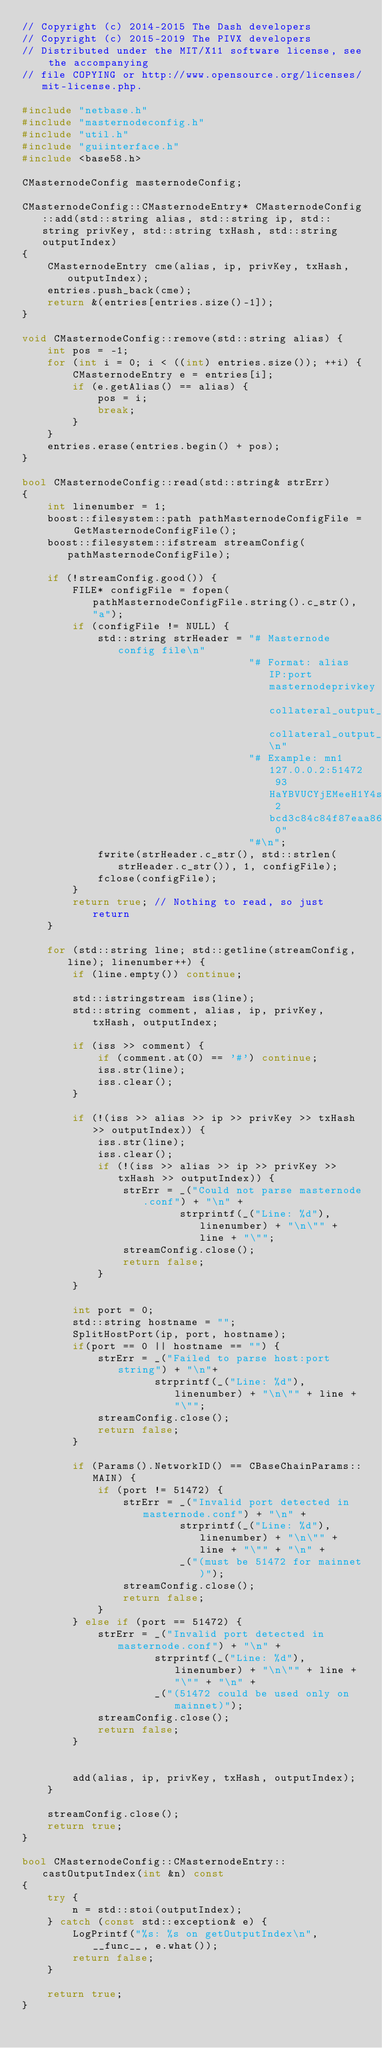<code> <loc_0><loc_0><loc_500><loc_500><_C++_>// Copyright (c) 2014-2015 The Dash developers
// Copyright (c) 2015-2019 The PIVX developers
// Distributed under the MIT/X11 software license, see the accompanying
// file COPYING or http://www.opensource.org/licenses/mit-license.php.

#include "netbase.h"
#include "masternodeconfig.h"
#include "util.h"
#include "guiinterface.h"
#include <base58.h>

CMasternodeConfig masternodeConfig;

CMasternodeConfig::CMasternodeEntry* CMasternodeConfig::add(std::string alias, std::string ip, std::string privKey, std::string txHash, std::string outputIndex)
{
    CMasternodeEntry cme(alias, ip, privKey, txHash, outputIndex);
    entries.push_back(cme);
    return &(entries[entries.size()-1]);
}

void CMasternodeConfig::remove(std::string alias) {
    int pos = -1;
    for (int i = 0; i < ((int) entries.size()); ++i) {
        CMasternodeEntry e = entries[i];
        if (e.getAlias() == alias) {
            pos = i;
            break;
        }
    }
    entries.erase(entries.begin() + pos);
}

bool CMasternodeConfig::read(std::string& strErr)
{
    int linenumber = 1;
    boost::filesystem::path pathMasternodeConfigFile = GetMasternodeConfigFile();
    boost::filesystem::ifstream streamConfig(pathMasternodeConfigFile);

    if (!streamConfig.good()) {
        FILE* configFile = fopen(pathMasternodeConfigFile.string().c_str(), "a");
        if (configFile != NULL) {
            std::string strHeader = "# Masternode config file\n"
                                    "# Format: alias IP:port masternodeprivkey collateral_output_txid collateral_output_index\n"
                                    "# Example: mn1 127.0.0.2:51472 93HaYBVUCYjEMeeH1Y4sBGLALQZE1Yc1K64xiqgX37tGBDQL8Xg 2bcd3c84c84f87eaa86e4e56834c92927a07f9e18718810b92e0d0324456a67c 0"
                                    "#\n";
            fwrite(strHeader.c_str(), std::strlen(strHeader.c_str()), 1, configFile);
            fclose(configFile);
        }
        return true; // Nothing to read, so just return
    }

    for (std::string line; std::getline(streamConfig, line); linenumber++) {
        if (line.empty()) continue;

        std::istringstream iss(line);
        std::string comment, alias, ip, privKey, txHash, outputIndex;

        if (iss >> comment) {
            if (comment.at(0) == '#') continue;
            iss.str(line);
            iss.clear();
        }

        if (!(iss >> alias >> ip >> privKey >> txHash >> outputIndex)) {
            iss.str(line);
            iss.clear();
            if (!(iss >> alias >> ip >> privKey >> txHash >> outputIndex)) {
                strErr = _("Could not parse masternode.conf") + "\n" +
                         strprintf(_("Line: %d"), linenumber) + "\n\"" + line + "\"";
                streamConfig.close();
                return false;
            }
        }

        int port = 0;
        std::string hostname = "";
        SplitHostPort(ip, port, hostname);
        if(port == 0 || hostname == "") {
            strErr = _("Failed to parse host:port string") + "\n"+
                     strprintf(_("Line: %d"), linenumber) + "\n\"" + line + "\"";
            streamConfig.close();
            return false;
        }

        if (Params().NetworkID() == CBaseChainParams::MAIN) {
            if (port != 51472) {
                strErr = _("Invalid port detected in masternode.conf") + "\n" +
                         strprintf(_("Line: %d"), linenumber) + "\n\"" + line + "\"" + "\n" +
                         _("(must be 51472 for mainnet)");
                streamConfig.close();
                return false;
            }
        } else if (port == 51472) {
            strErr = _("Invalid port detected in masternode.conf") + "\n" +
                     strprintf(_("Line: %d"), linenumber) + "\n\"" + line + "\"" + "\n" +
                     _("(51472 could be used only on mainnet)");
            streamConfig.close();
            return false;
        }


        add(alias, ip, privKey, txHash, outputIndex);
    }

    streamConfig.close();
    return true;
}

bool CMasternodeConfig::CMasternodeEntry::castOutputIndex(int &n) const
{
    try {
        n = std::stoi(outputIndex);
    } catch (const std::exception& e) {
        LogPrintf("%s: %s on getOutputIndex\n", __func__, e.what());
        return false;
    }

    return true;
}
</code> 